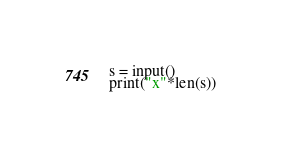Convert code to text. <code><loc_0><loc_0><loc_500><loc_500><_Python_>s = input()
print("x"*len(s))
</code> 